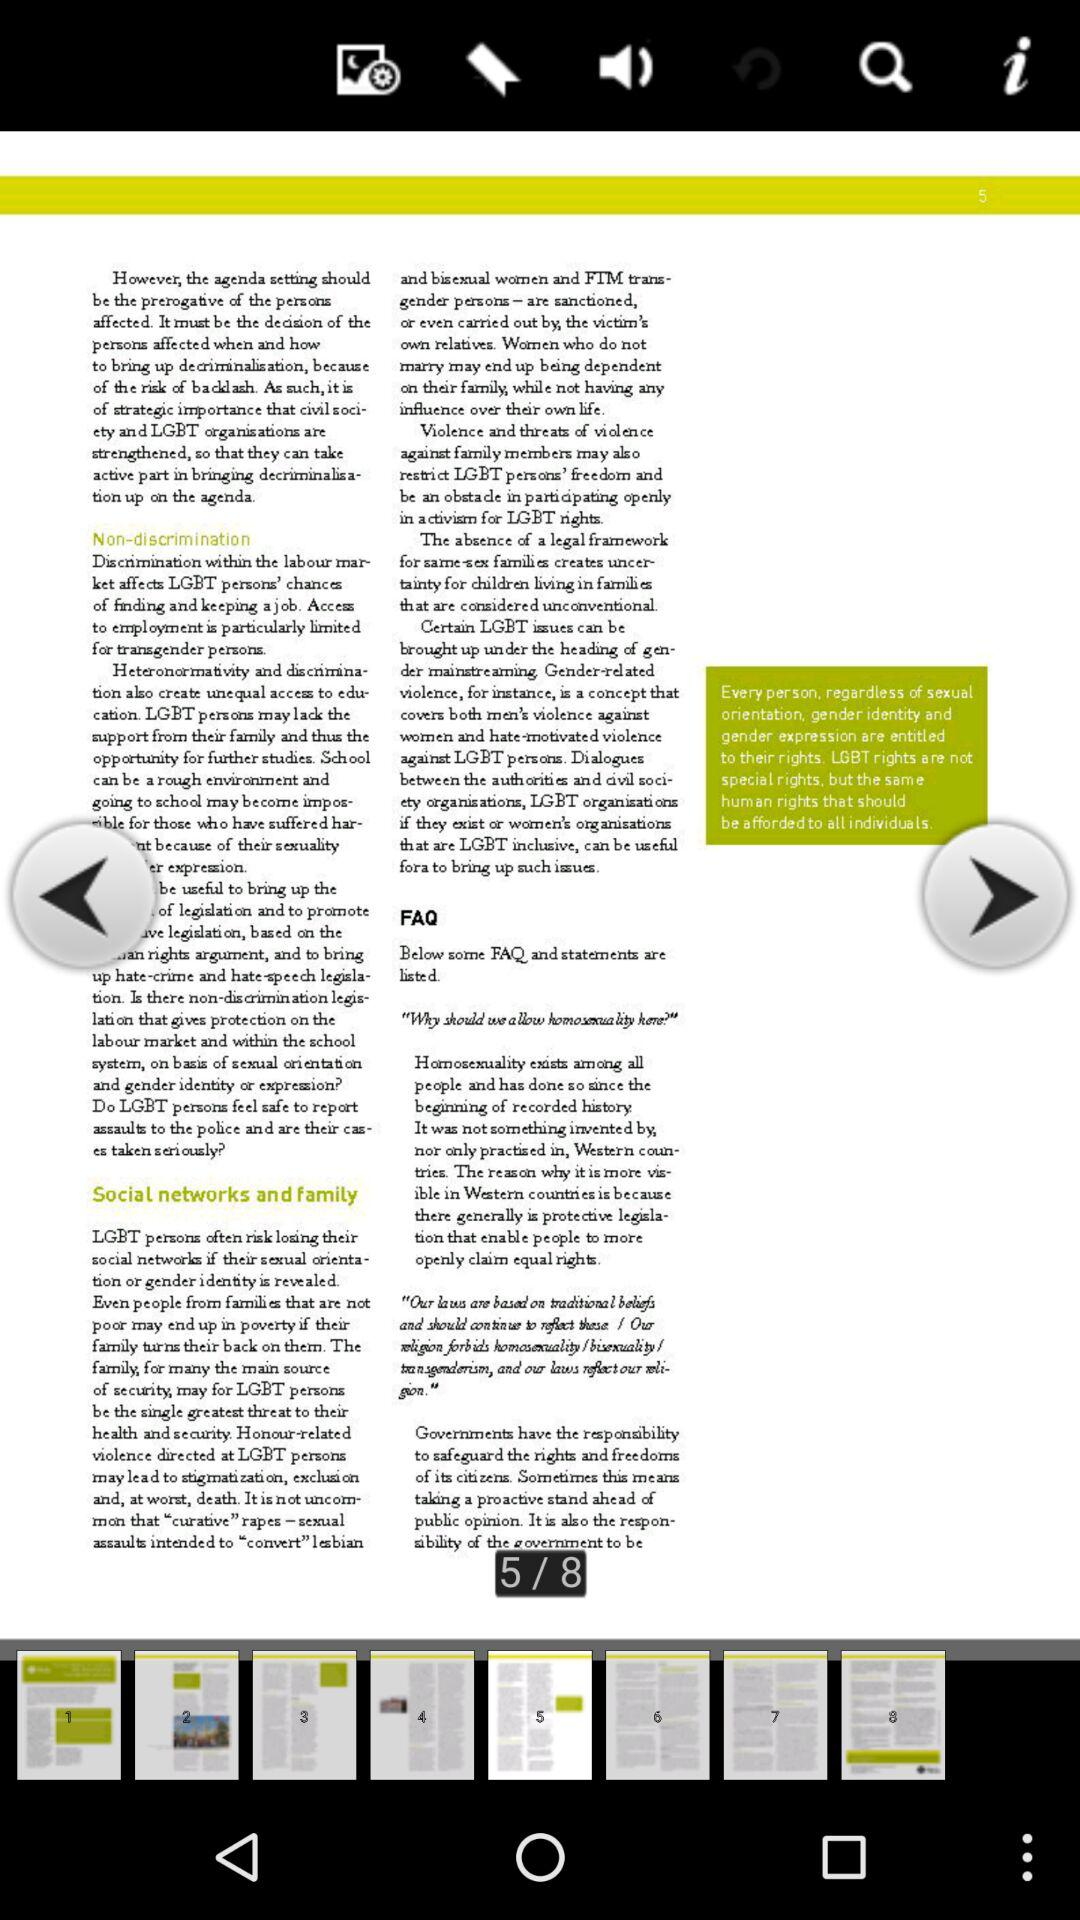How many pages in total are there? There are 8 pages. 